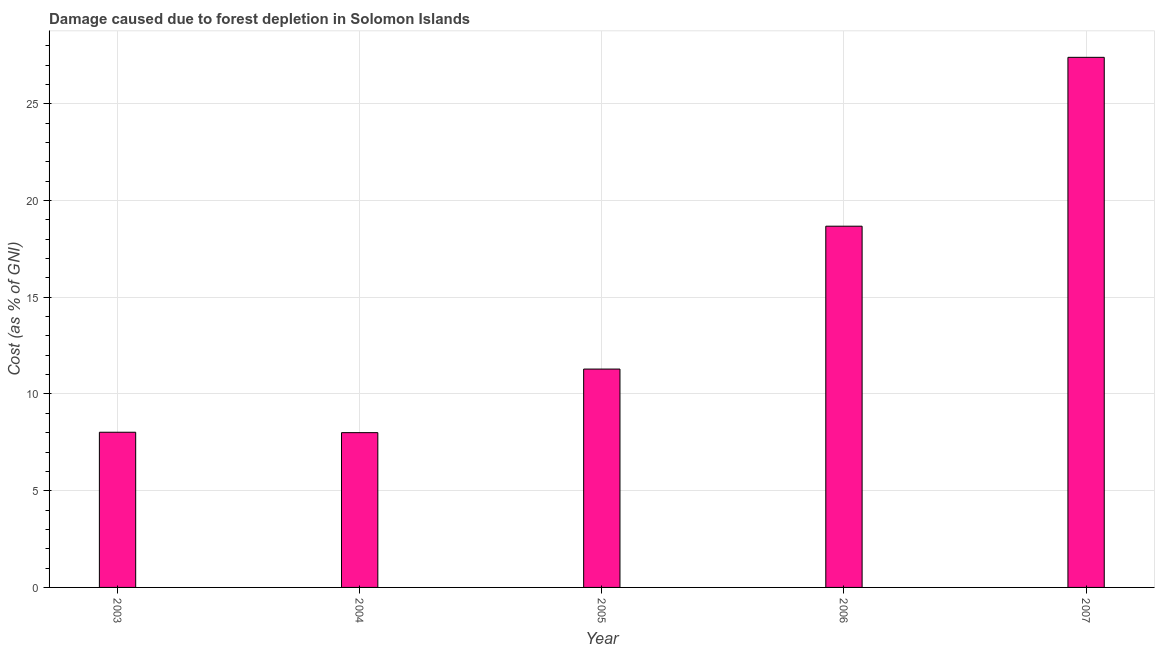What is the title of the graph?
Ensure brevity in your answer.  Damage caused due to forest depletion in Solomon Islands. What is the label or title of the Y-axis?
Provide a short and direct response. Cost (as % of GNI). What is the damage caused due to forest depletion in 2004?
Provide a short and direct response. 8. Across all years, what is the maximum damage caused due to forest depletion?
Offer a terse response. 27.4. Across all years, what is the minimum damage caused due to forest depletion?
Keep it short and to the point. 8. In which year was the damage caused due to forest depletion maximum?
Give a very brief answer. 2007. What is the sum of the damage caused due to forest depletion?
Offer a terse response. 73.39. What is the difference between the damage caused due to forest depletion in 2003 and 2007?
Make the answer very short. -19.38. What is the average damage caused due to forest depletion per year?
Keep it short and to the point. 14.68. What is the median damage caused due to forest depletion?
Give a very brief answer. 11.29. What is the ratio of the damage caused due to forest depletion in 2006 to that in 2007?
Provide a short and direct response. 0.68. Is the difference between the damage caused due to forest depletion in 2004 and 2007 greater than the difference between any two years?
Provide a succinct answer. Yes. What is the difference between the highest and the second highest damage caused due to forest depletion?
Offer a very short reply. 8.73. What is the difference between the highest and the lowest damage caused due to forest depletion?
Your answer should be very brief. 19.4. In how many years, is the damage caused due to forest depletion greater than the average damage caused due to forest depletion taken over all years?
Provide a succinct answer. 2. What is the difference between two consecutive major ticks on the Y-axis?
Offer a terse response. 5. What is the Cost (as % of GNI) of 2003?
Provide a succinct answer. 8.02. What is the Cost (as % of GNI) in 2004?
Your response must be concise. 8. What is the Cost (as % of GNI) in 2005?
Your response must be concise. 11.29. What is the Cost (as % of GNI) of 2006?
Your answer should be compact. 18.67. What is the Cost (as % of GNI) of 2007?
Provide a succinct answer. 27.4. What is the difference between the Cost (as % of GNI) in 2003 and 2004?
Your answer should be very brief. 0.02. What is the difference between the Cost (as % of GNI) in 2003 and 2005?
Keep it short and to the point. -3.27. What is the difference between the Cost (as % of GNI) in 2003 and 2006?
Provide a short and direct response. -10.65. What is the difference between the Cost (as % of GNI) in 2003 and 2007?
Provide a succinct answer. -19.38. What is the difference between the Cost (as % of GNI) in 2004 and 2005?
Provide a short and direct response. -3.29. What is the difference between the Cost (as % of GNI) in 2004 and 2006?
Your response must be concise. -10.67. What is the difference between the Cost (as % of GNI) in 2004 and 2007?
Your answer should be very brief. -19.4. What is the difference between the Cost (as % of GNI) in 2005 and 2006?
Your answer should be compact. -7.39. What is the difference between the Cost (as % of GNI) in 2005 and 2007?
Your answer should be compact. -16.12. What is the difference between the Cost (as % of GNI) in 2006 and 2007?
Make the answer very short. -8.73. What is the ratio of the Cost (as % of GNI) in 2003 to that in 2005?
Ensure brevity in your answer.  0.71. What is the ratio of the Cost (as % of GNI) in 2003 to that in 2006?
Your answer should be very brief. 0.43. What is the ratio of the Cost (as % of GNI) in 2003 to that in 2007?
Give a very brief answer. 0.29. What is the ratio of the Cost (as % of GNI) in 2004 to that in 2005?
Make the answer very short. 0.71. What is the ratio of the Cost (as % of GNI) in 2004 to that in 2006?
Make the answer very short. 0.43. What is the ratio of the Cost (as % of GNI) in 2004 to that in 2007?
Give a very brief answer. 0.29. What is the ratio of the Cost (as % of GNI) in 2005 to that in 2006?
Provide a succinct answer. 0.6. What is the ratio of the Cost (as % of GNI) in 2005 to that in 2007?
Ensure brevity in your answer.  0.41. What is the ratio of the Cost (as % of GNI) in 2006 to that in 2007?
Your answer should be compact. 0.68. 